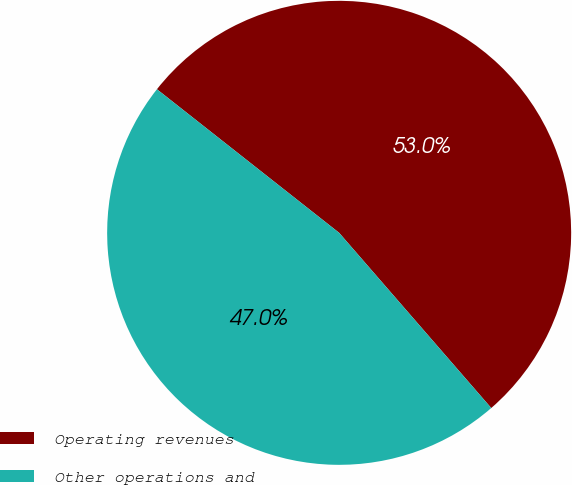Convert chart to OTSL. <chart><loc_0><loc_0><loc_500><loc_500><pie_chart><fcel>Operating revenues<fcel>Other operations and<nl><fcel>53.0%<fcel>47.0%<nl></chart> 